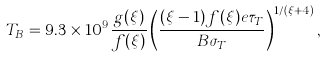Convert formula to latex. <formula><loc_0><loc_0><loc_500><loc_500>T _ { B } = 9 . 3 \times 1 0 ^ { 9 } \frac { g ( \xi ) } { f ( \xi ) } \left ( \frac { ( \xi - 1 ) f ( \xi ) e \tau _ { T } } { B \sigma _ { T } } \right ) ^ { 1 / ( \xi + 4 ) } ,</formula> 